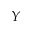Convert formula to latex. <formula><loc_0><loc_0><loc_500><loc_500>Y</formula> 